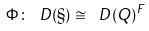<formula> <loc_0><loc_0><loc_500><loc_500>\Phi \colon \ D ( \S ) \cong \ D ( Q ) ^ { F }</formula> 